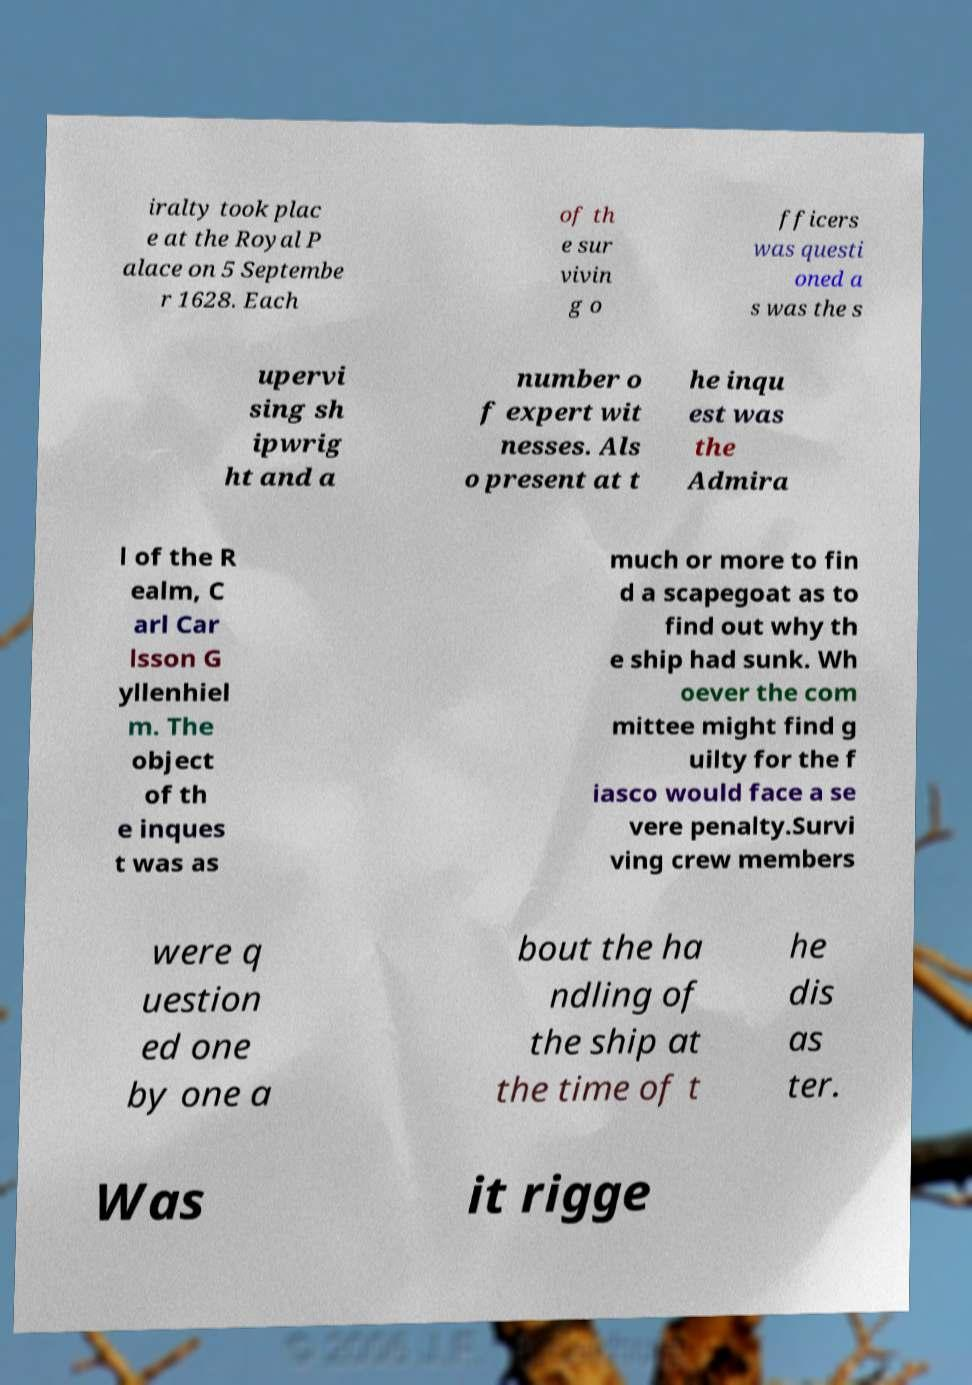Please read and relay the text visible in this image. What does it say? iralty took plac e at the Royal P alace on 5 Septembe r 1628. Each of th e sur vivin g o fficers was questi oned a s was the s upervi sing sh ipwrig ht and a number o f expert wit nesses. Als o present at t he inqu est was the Admira l of the R ealm, C arl Car lsson G yllenhiel m. The object of th e inques t was as much or more to fin d a scapegoat as to find out why th e ship had sunk. Wh oever the com mittee might find g uilty for the f iasco would face a se vere penalty.Survi ving crew members were q uestion ed one by one a bout the ha ndling of the ship at the time of t he dis as ter. Was it rigge 